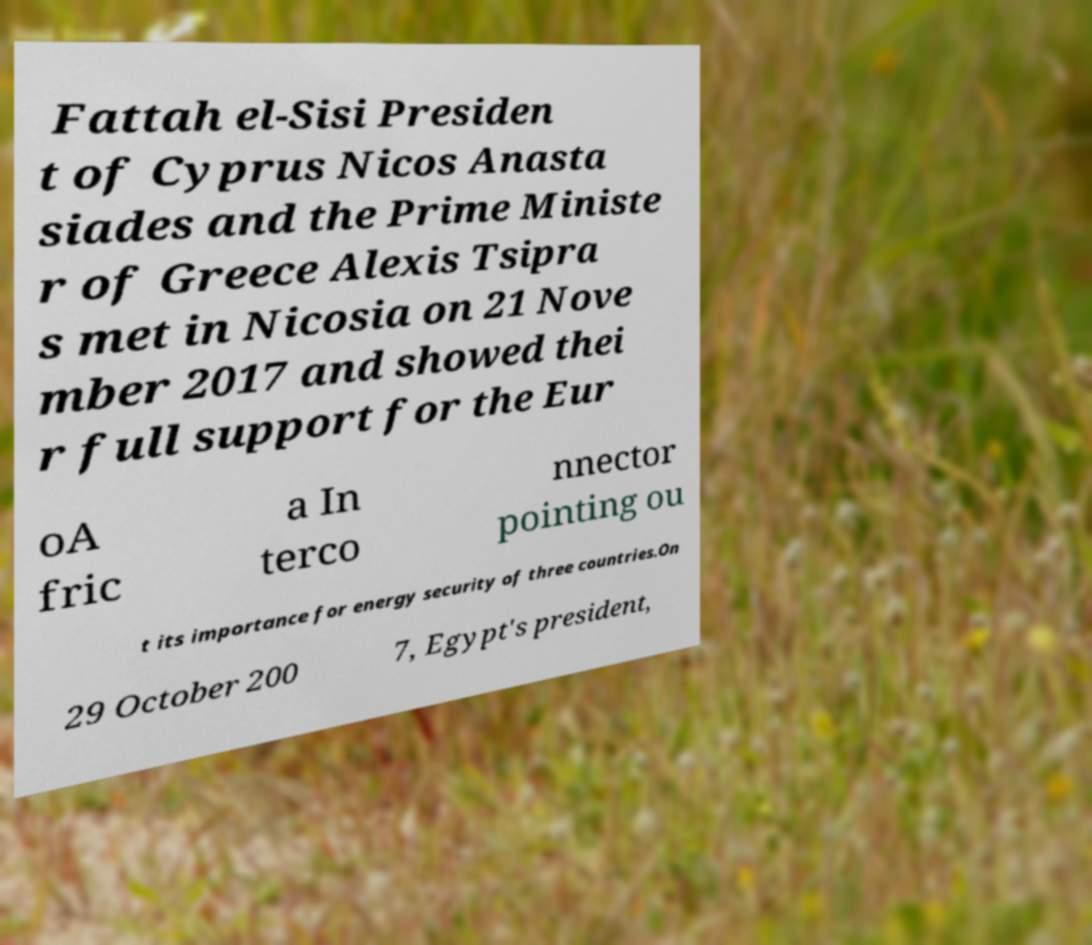Can you read and provide the text displayed in the image?This photo seems to have some interesting text. Can you extract and type it out for me? Fattah el-Sisi Presiden t of Cyprus Nicos Anasta siades and the Prime Ministe r of Greece Alexis Tsipra s met in Nicosia on 21 Nove mber 2017 and showed thei r full support for the Eur oA fric a In terco nnector pointing ou t its importance for energy security of three countries.On 29 October 200 7, Egypt's president, 